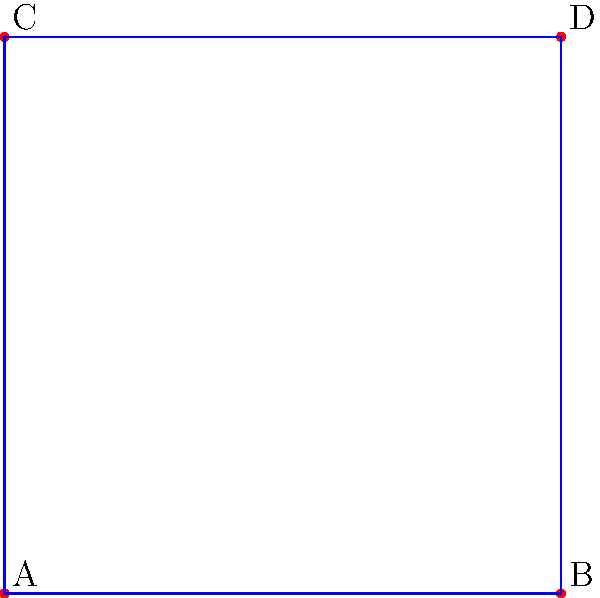In a high-altitude rescue operation, a team of four members (A, B, C, and D) is arranged in a square formation as shown in the diagram. How many unique arrangements of the team members are possible while maintaining this square formation? To solve this problem, we need to consider the permutations of the rescue team members while maintaining the square formation. Let's approach this step-by-step:

1. First, note that we have 4 positions in the square formation and 4 team members.

2. For the first position, we have 4 choices as any team member can occupy it.

3. After placing the first member, we have 3 choices for the second position.

4. For the third position, we have 2 choices remaining.

5. The last position will be filled by the remaining team member, so we have only 1 choice.

6. According to the multiplication principle, the total number of arrangements is:

   $4 \times 3 \times 2 \times 1 = 24$

7. However, we need to consider that rotations of the square formation produce equivalent arrangements. There are 4 possible rotations (0°, 90°, 180°, 270°) for each arrangement.

8. Therefore, we need to divide our total by 4 to account for these rotations:

   $\frac{24}{4} = 6$

Thus, there are 6 unique arrangements of the team members in the square formation.
Answer: 6 unique arrangements 